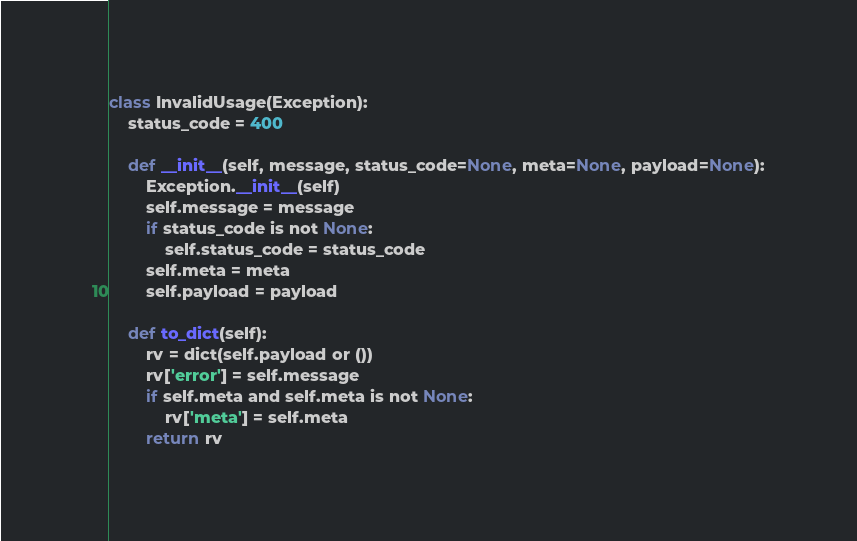Convert code to text. <code><loc_0><loc_0><loc_500><loc_500><_Python_>class InvalidUsage(Exception):
    status_code = 400

    def __init__(self, message, status_code=None, meta=None, payload=None):
        Exception.__init__(self)
        self.message = message
        if status_code is not None:
            self.status_code = status_code
        self.meta = meta
        self.payload = payload

    def to_dict(self):
        rv = dict(self.payload or ())
        rv['error'] = self.message
        if self.meta and self.meta is not None:
            rv['meta'] = self.meta
        return rv
</code> 